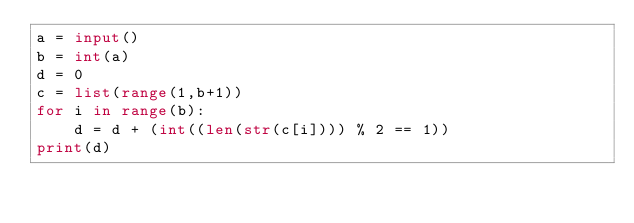Convert code to text. <code><loc_0><loc_0><loc_500><loc_500><_Python_>a = input()
b = int(a)
d = 0
c = list(range(1,b+1))
for i in range(b):
    d = d + (int((len(str(c[i]))) % 2 == 1))
print(d)</code> 